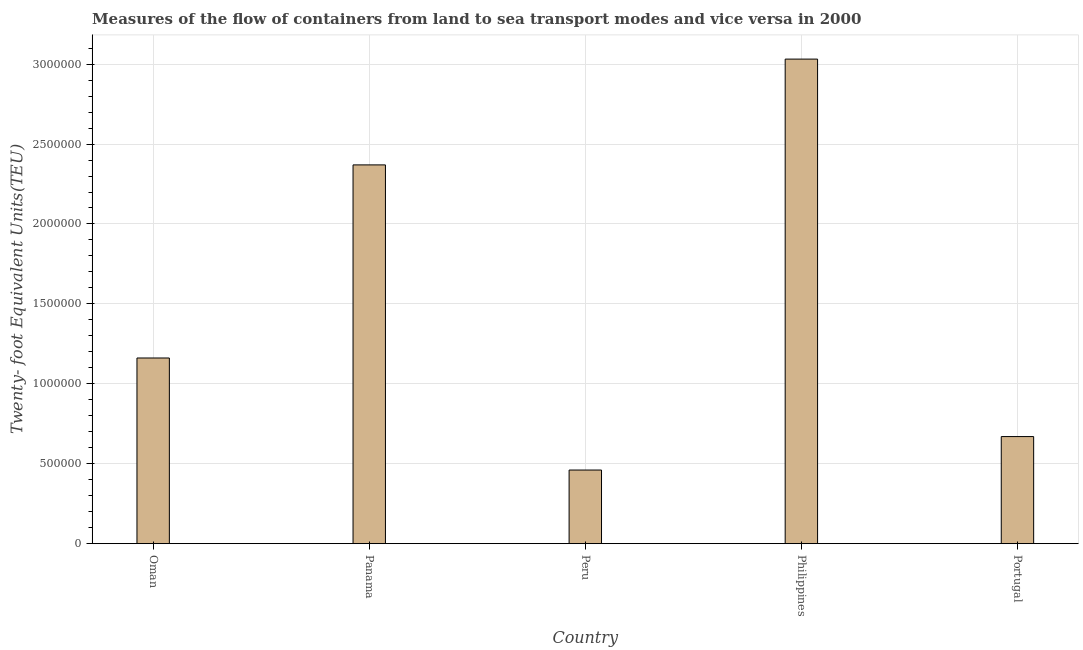Does the graph contain any zero values?
Keep it short and to the point. No. What is the title of the graph?
Your response must be concise. Measures of the flow of containers from land to sea transport modes and vice versa in 2000. What is the label or title of the X-axis?
Your response must be concise. Country. What is the label or title of the Y-axis?
Your answer should be compact. Twenty- foot Equivalent Units(TEU). What is the container port traffic in Panama?
Give a very brief answer. 2.37e+06. Across all countries, what is the maximum container port traffic?
Make the answer very short. 3.03e+06. Across all countries, what is the minimum container port traffic?
Keep it short and to the point. 4.61e+05. In which country was the container port traffic maximum?
Provide a short and direct response. Philippines. What is the sum of the container port traffic?
Give a very brief answer. 7.69e+06. What is the difference between the container port traffic in Panama and Philippines?
Your response must be concise. -6.62e+05. What is the average container port traffic per country?
Offer a very short reply. 1.54e+06. What is the median container port traffic?
Provide a short and direct response. 1.16e+06. What is the ratio of the container port traffic in Panama to that in Philippines?
Your response must be concise. 0.78. Is the container port traffic in Panama less than that in Portugal?
Keep it short and to the point. No. What is the difference between the highest and the second highest container port traffic?
Give a very brief answer. 6.62e+05. What is the difference between the highest and the lowest container port traffic?
Provide a succinct answer. 2.57e+06. What is the difference between two consecutive major ticks on the Y-axis?
Give a very brief answer. 5.00e+05. Are the values on the major ticks of Y-axis written in scientific E-notation?
Offer a terse response. No. What is the Twenty- foot Equivalent Units(TEU) of Oman?
Your response must be concise. 1.16e+06. What is the Twenty- foot Equivalent Units(TEU) of Panama?
Make the answer very short. 2.37e+06. What is the Twenty- foot Equivalent Units(TEU) of Peru?
Provide a succinct answer. 4.61e+05. What is the Twenty- foot Equivalent Units(TEU) of Philippines?
Provide a succinct answer. 3.03e+06. What is the Twenty- foot Equivalent Units(TEU) in Portugal?
Provide a short and direct response. 6.70e+05. What is the difference between the Twenty- foot Equivalent Units(TEU) in Oman and Panama?
Make the answer very short. -1.21e+06. What is the difference between the Twenty- foot Equivalent Units(TEU) in Oman and Peru?
Keep it short and to the point. 7.01e+05. What is the difference between the Twenty- foot Equivalent Units(TEU) in Oman and Philippines?
Provide a succinct answer. -1.87e+06. What is the difference between the Twenty- foot Equivalent Units(TEU) in Oman and Portugal?
Provide a succinct answer. 4.92e+05. What is the difference between the Twenty- foot Equivalent Units(TEU) in Panama and Peru?
Keep it short and to the point. 1.91e+06. What is the difference between the Twenty- foot Equivalent Units(TEU) in Panama and Philippines?
Offer a very short reply. -6.62e+05. What is the difference between the Twenty- foot Equivalent Units(TEU) in Panama and Portugal?
Make the answer very short. 1.70e+06. What is the difference between the Twenty- foot Equivalent Units(TEU) in Peru and Philippines?
Give a very brief answer. -2.57e+06. What is the difference between the Twenty- foot Equivalent Units(TEU) in Peru and Portugal?
Provide a short and direct response. -2.09e+05. What is the difference between the Twenty- foot Equivalent Units(TEU) in Philippines and Portugal?
Keep it short and to the point. 2.36e+06. What is the ratio of the Twenty- foot Equivalent Units(TEU) in Oman to that in Panama?
Provide a short and direct response. 0.49. What is the ratio of the Twenty- foot Equivalent Units(TEU) in Oman to that in Peru?
Offer a very short reply. 2.52. What is the ratio of the Twenty- foot Equivalent Units(TEU) in Oman to that in Philippines?
Offer a terse response. 0.38. What is the ratio of the Twenty- foot Equivalent Units(TEU) in Oman to that in Portugal?
Offer a very short reply. 1.73. What is the ratio of the Twenty- foot Equivalent Units(TEU) in Panama to that in Peru?
Keep it short and to the point. 5.14. What is the ratio of the Twenty- foot Equivalent Units(TEU) in Panama to that in Philippines?
Provide a succinct answer. 0.78. What is the ratio of the Twenty- foot Equivalent Units(TEU) in Panama to that in Portugal?
Give a very brief answer. 3.54. What is the ratio of the Twenty- foot Equivalent Units(TEU) in Peru to that in Philippines?
Your response must be concise. 0.15. What is the ratio of the Twenty- foot Equivalent Units(TEU) in Peru to that in Portugal?
Provide a short and direct response. 0.69. What is the ratio of the Twenty- foot Equivalent Units(TEU) in Philippines to that in Portugal?
Your answer should be very brief. 4.53. 